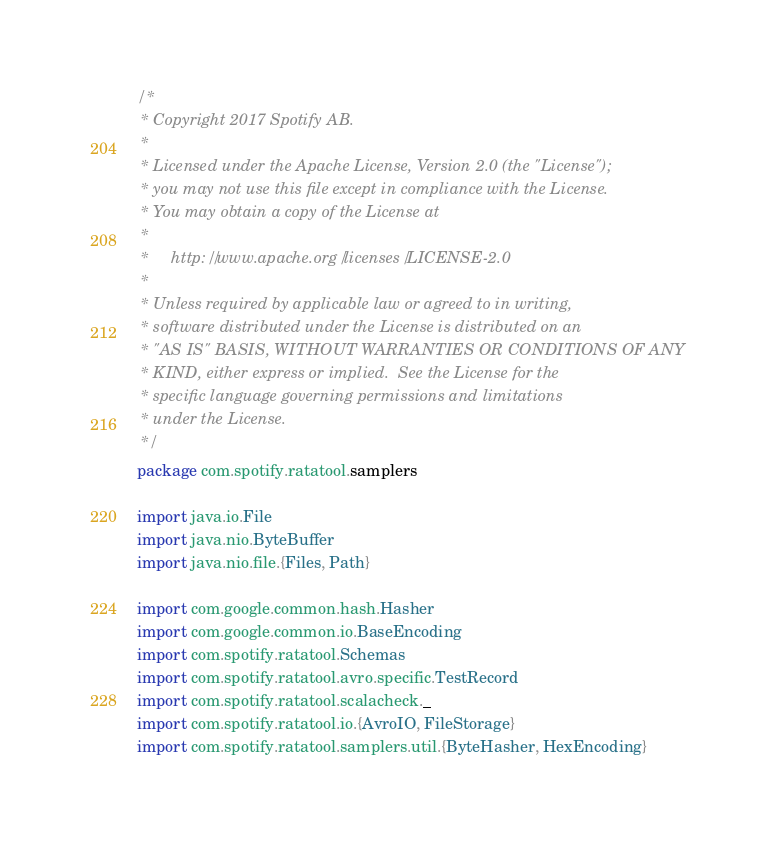<code> <loc_0><loc_0><loc_500><loc_500><_Scala_>/*
 * Copyright 2017 Spotify AB.
 *
 * Licensed under the Apache License, Version 2.0 (the "License");
 * you may not use this file except in compliance with the License.
 * You may obtain a copy of the License at
 *
 *     http://www.apache.org/licenses/LICENSE-2.0
 *
 * Unless required by applicable law or agreed to in writing,
 * software distributed under the License is distributed on an
 * "AS IS" BASIS, WITHOUT WARRANTIES OR CONDITIONS OF ANY
 * KIND, either express or implied.  See the License for the
 * specific language governing permissions and limitations
 * under the License.
 */
package com.spotify.ratatool.samplers

import java.io.File
import java.nio.ByteBuffer
import java.nio.file.{Files, Path}

import com.google.common.hash.Hasher
import com.google.common.io.BaseEncoding
import com.spotify.ratatool.Schemas
import com.spotify.ratatool.avro.specific.TestRecord
import com.spotify.ratatool.scalacheck._
import com.spotify.ratatool.io.{AvroIO, FileStorage}
import com.spotify.ratatool.samplers.util.{ByteHasher, HexEncoding}</code> 